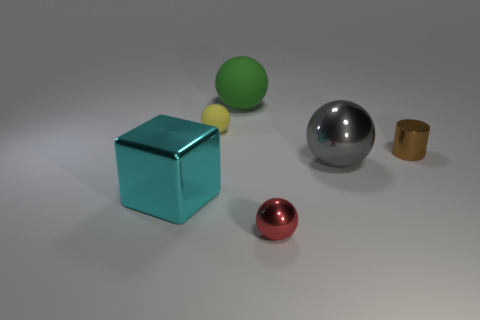Subtract all big gray balls. How many balls are left? 3 Add 3 cyan blocks. How many objects exist? 9 Subtract all red balls. How many balls are left? 3 Subtract all red spheres. Subtract all yellow blocks. How many spheres are left? 3 Add 2 brown objects. How many brown objects exist? 3 Subtract 1 gray balls. How many objects are left? 5 Subtract all cylinders. How many objects are left? 5 Subtract all large gray metal spheres. Subtract all tiny yellow cylinders. How many objects are left? 5 Add 1 red spheres. How many red spheres are left? 2 